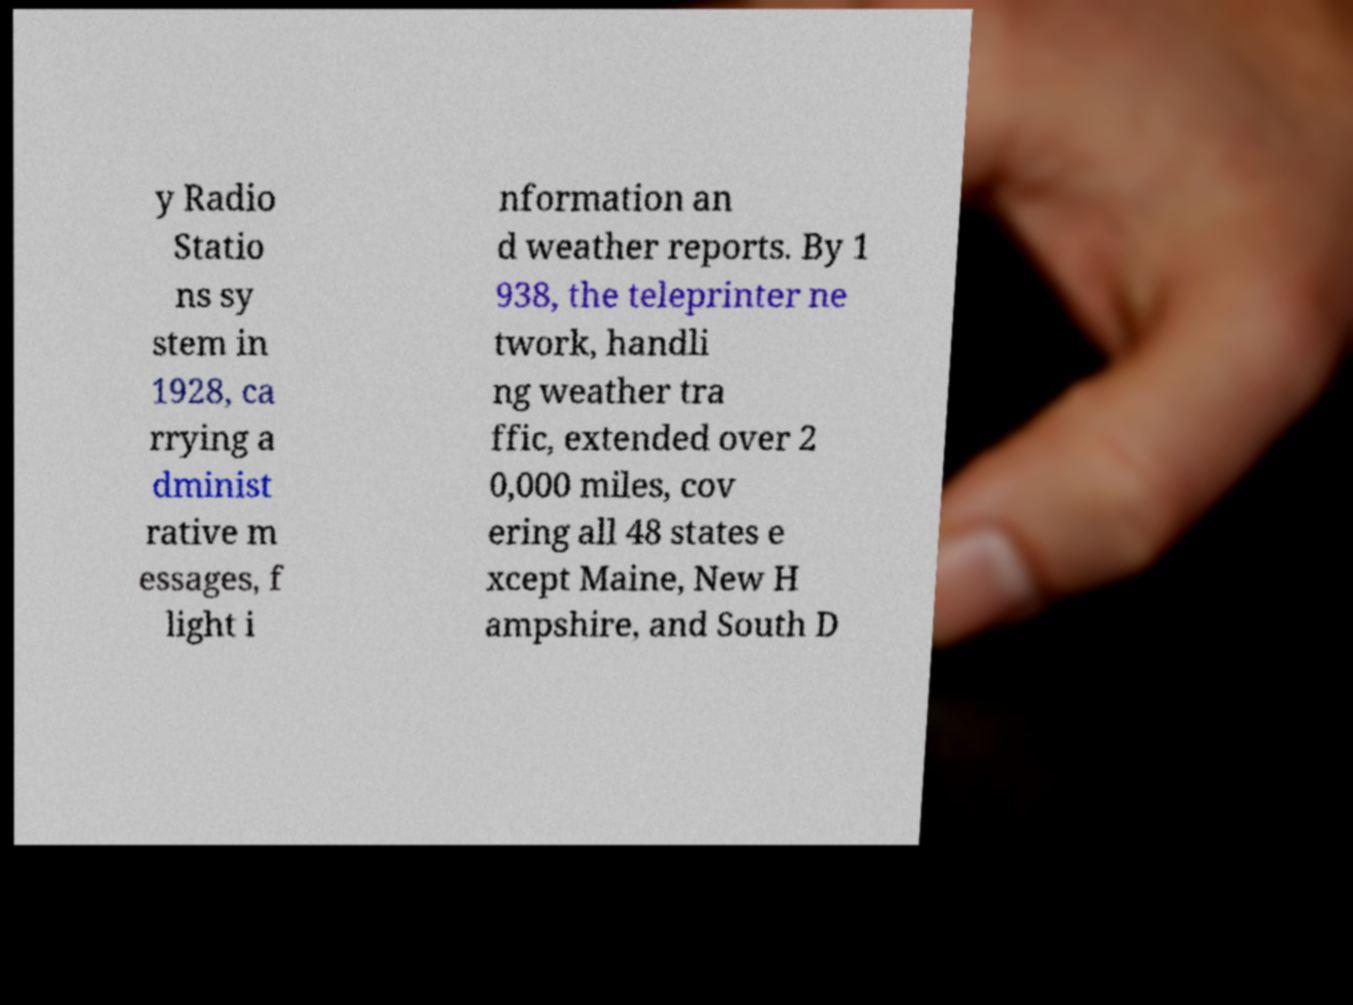For documentation purposes, I need the text within this image transcribed. Could you provide that? y Radio Statio ns sy stem in 1928, ca rrying a dminist rative m essages, f light i nformation an d weather reports. By 1 938, the teleprinter ne twork, handli ng weather tra ffic, extended over 2 0,000 miles, cov ering all 48 states e xcept Maine, New H ampshire, and South D 